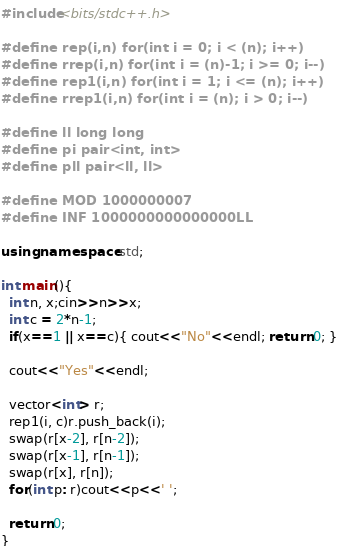<code> <loc_0><loc_0><loc_500><loc_500><_C++_>#include<bits/stdc++.h>

#define rep(i,n) for(int i = 0; i < (n); i++)
#define rrep(i,n) for(int i = (n)-1; i >= 0; i--)
#define rep1(i,n) for(int i = 1; i <= (n); i++)
#define rrep1(i,n) for(int i = (n); i > 0; i--)

#define ll long long
#define pi pair<int, int>
#define pll pair<ll, ll>

#define MOD 1000000007
#define INF 1000000000000000LL

using namespace std;

int main(){
  int n, x;cin>>n>>x;
  int c = 2*n-1;
  if(x==1 || x==c){ cout<<"No"<<endl; return 0; }

  cout<<"Yes"<<endl;

  vector<int> r;
  rep1(i, c)r.push_back(i);
  swap(r[x-2], r[n-2]);
  swap(r[x-1], r[n-1]);
  swap(r[x], r[n]);
  for(int p: r)cout<<p<<' ';

  return 0;
}
</code> 